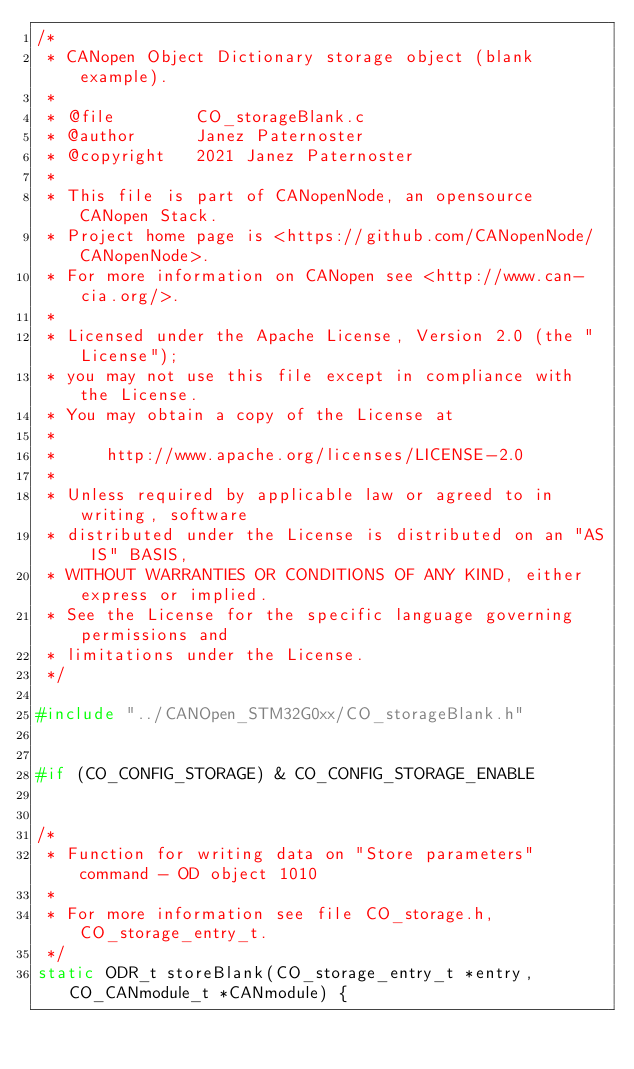<code> <loc_0><loc_0><loc_500><loc_500><_C_>/*
 * CANopen Object Dictionary storage object (blank example).
 *
 * @file        CO_storageBlank.c
 * @author      Janez Paternoster
 * @copyright   2021 Janez Paternoster
 *
 * This file is part of CANopenNode, an opensource CANopen Stack.
 * Project home page is <https://github.com/CANopenNode/CANopenNode>.
 * For more information on CANopen see <http://www.can-cia.org/>.
 *
 * Licensed under the Apache License, Version 2.0 (the "License");
 * you may not use this file except in compliance with the License.
 * You may obtain a copy of the License at
 *
 *     http://www.apache.org/licenses/LICENSE-2.0
 *
 * Unless required by applicable law or agreed to in writing, software
 * distributed under the License is distributed on an "AS IS" BASIS,
 * WITHOUT WARRANTIES OR CONDITIONS OF ANY KIND, either express or implied.
 * See the License for the specific language governing permissions and
 * limitations under the License.
 */

#include "../CANOpen_STM32G0xx/CO_storageBlank.h"


#if (CO_CONFIG_STORAGE) & CO_CONFIG_STORAGE_ENABLE


/*
 * Function for writing data on "Store parameters" command - OD object 1010
 *
 * For more information see file CO_storage.h, CO_storage_entry_t.
 */
static ODR_t storeBlank(CO_storage_entry_t *entry, CO_CANmodule_t *CANmodule) {
</code> 